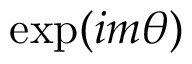<formula> <loc_0><loc_0><loc_500><loc_500>\exp ( i m \theta )</formula> 